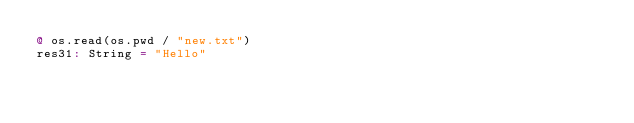Convert code to text. <code><loc_0><loc_0><loc_500><loc_500><_Scala_>@ os.read(os.pwd / "new.txt")
res31: String = "Hello"
</code> 